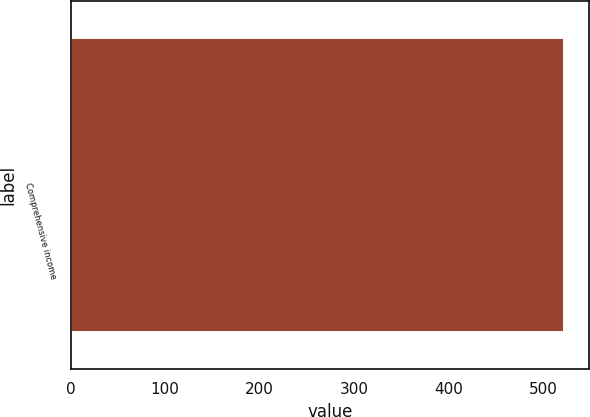<chart> <loc_0><loc_0><loc_500><loc_500><bar_chart><fcel>Comprehensive income<nl><fcel>522.1<nl></chart> 